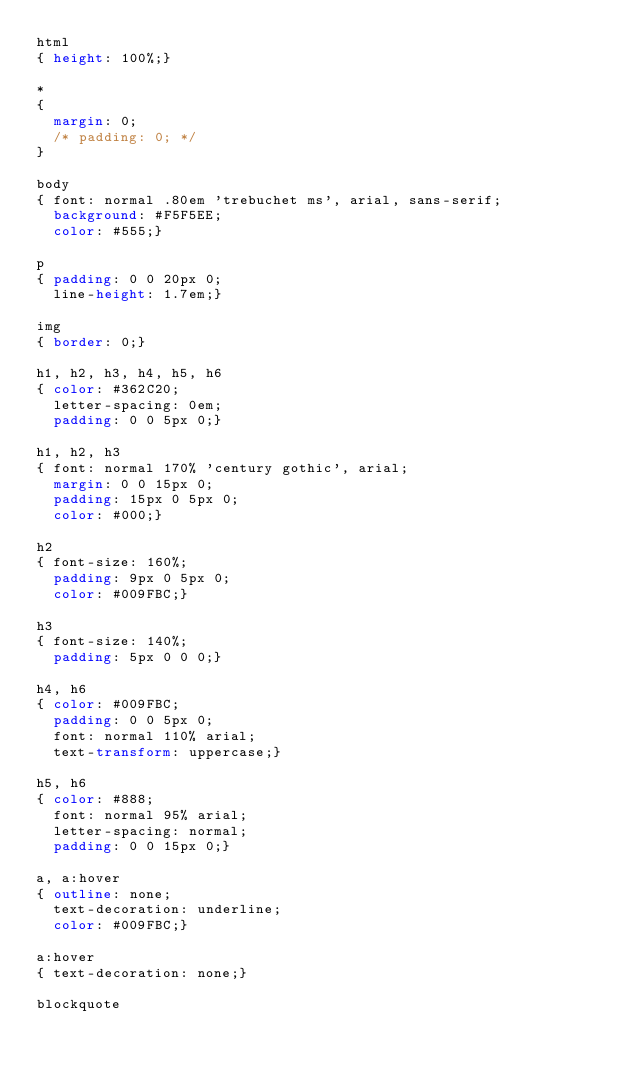Convert code to text. <code><loc_0><loc_0><loc_500><loc_500><_CSS_>html
{ height: 100%;}

*
{ 
	margin: 0;
	/* padding: 0; */
}

body
{ font: normal .80em 'trebuchet ms', arial, sans-serif;
  background: #F5F5EE;
  color: #555;}

p
{ padding: 0 0 20px 0;
  line-height: 1.7em;}

img
{ border: 0;}

h1, h2, h3, h4, h5, h6 
{ color: #362C20;
  letter-spacing: 0em;
  padding: 0 0 5px 0;}

h1, h2, h3
{ font: normal 170% 'century gothic', arial;
  margin: 0 0 15px 0;
  padding: 15px 0 5px 0;
  color: #000;}

h2
{ font-size: 160%;
  padding: 9px 0 5px 0;
  color: #009FBC;}

h3
{ font-size: 140%;
  padding: 5px 0 0 0;}

h4, h6
{ color: #009FBC;
  padding: 0 0 5px 0;
  font: normal 110% arial;
  text-transform: uppercase;}

h5, h6
{ color: #888;
  font: normal 95% arial;
  letter-spacing: normal;
  padding: 0 0 15px 0;}

a, a:hover
{ outline: none;
  text-decoration: underline;
  color: #009FBC;}

a:hover
{ text-decoration: none;}

blockquote</code> 